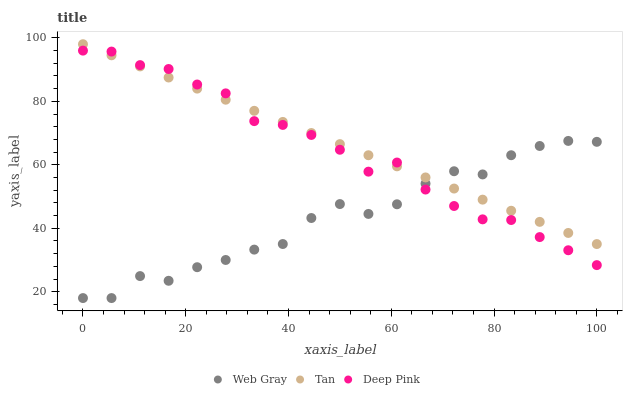Does Web Gray have the minimum area under the curve?
Answer yes or no. Yes. Does Tan have the maximum area under the curve?
Answer yes or no. Yes. Does Deep Pink have the minimum area under the curve?
Answer yes or no. No. Does Deep Pink have the maximum area under the curve?
Answer yes or no. No. Is Tan the smoothest?
Answer yes or no. Yes. Is Web Gray the roughest?
Answer yes or no. Yes. Is Deep Pink the smoothest?
Answer yes or no. No. Is Deep Pink the roughest?
Answer yes or no. No. Does Web Gray have the lowest value?
Answer yes or no. Yes. Does Deep Pink have the lowest value?
Answer yes or no. No. Does Tan have the highest value?
Answer yes or no. Yes. Does Deep Pink have the highest value?
Answer yes or no. No. Does Web Gray intersect Deep Pink?
Answer yes or no. Yes. Is Web Gray less than Deep Pink?
Answer yes or no. No. Is Web Gray greater than Deep Pink?
Answer yes or no. No. 